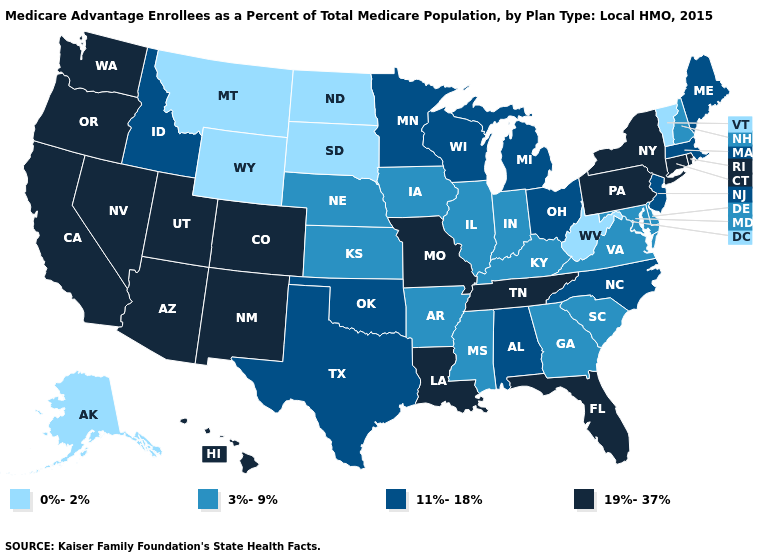What is the value of Nebraska?
Be succinct. 3%-9%. How many symbols are there in the legend?
Be succinct. 4. What is the lowest value in the USA?
Quick response, please. 0%-2%. How many symbols are there in the legend?
Keep it brief. 4. Which states have the lowest value in the South?
Answer briefly. West Virginia. What is the value of Vermont?
Be succinct. 0%-2%. Name the states that have a value in the range 11%-18%?
Short answer required. Alabama, Idaho, Massachusetts, Maine, Michigan, Minnesota, North Carolina, New Jersey, Ohio, Oklahoma, Texas, Wisconsin. Does Colorado have a higher value than Delaware?
Be succinct. Yes. What is the value of Massachusetts?
Concise answer only. 11%-18%. What is the lowest value in the USA?
Concise answer only. 0%-2%. Does Massachusetts have the highest value in the USA?
Concise answer only. No. Does New Mexico have the highest value in the West?
Give a very brief answer. Yes. Name the states that have a value in the range 11%-18%?
Concise answer only. Alabama, Idaho, Massachusetts, Maine, Michigan, Minnesota, North Carolina, New Jersey, Ohio, Oklahoma, Texas, Wisconsin. Which states have the highest value in the USA?
Write a very short answer. Arizona, California, Colorado, Connecticut, Florida, Hawaii, Louisiana, Missouri, New Mexico, Nevada, New York, Oregon, Pennsylvania, Rhode Island, Tennessee, Utah, Washington. Does Delaware have the lowest value in the South?
Give a very brief answer. No. 